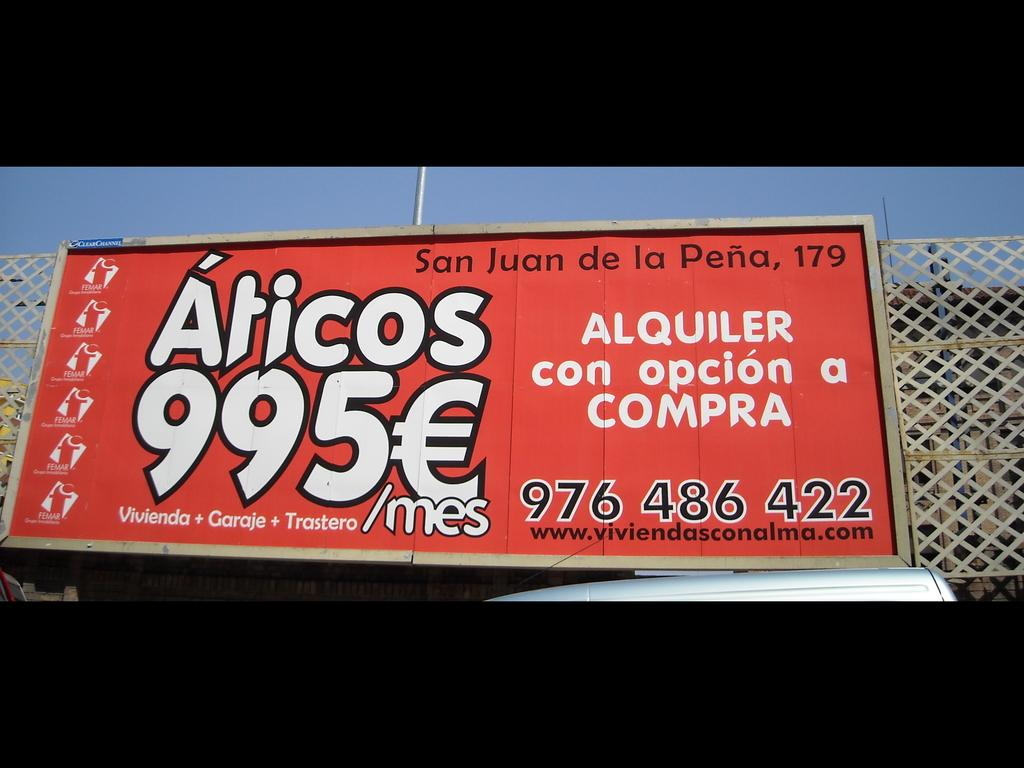What is the main object in the image that has a red color? There is a red color board in the image. How is the red color board positioned in the image? The red color board is attached to a fencing. What other object can be seen in the image besides the red color board? There is a pole in the image. What is the color of the sky in the image? The sky is blue in color. What type of fork is used to cover the red color board in the image? There is no fork present in the image, and the red color board is not being covered. 